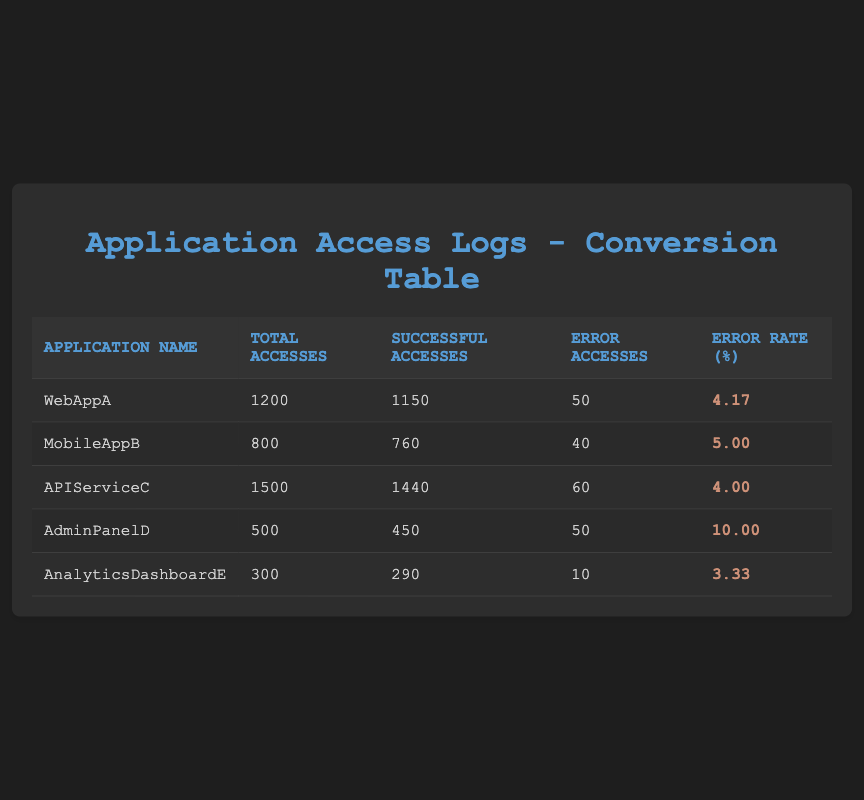What is the total number of accesses for WebAppA? The table shows the total accesses for WebAppA in the "Total Accesses" column, which is directly stated as 1200.
Answer: 1200 What is the error rate for APIServiceC? The error rate for APIServiceC can be found in the "Error Rate (%)" column next to the application's name, which shows a value of 4.00.
Answer: 4.00 Which application has the highest error rate? By comparing the "Error Rate (%)" values, AdminPanelD shows the highest value at 10.00, making it the application with the highest error rate.
Answer: AdminPanelD What is the sum of successful accesses for all applications? The successful accesses are summed up from each application's "Successful Accesses" values: 1150 + 760 + 1440 + 450 + 290 = 4090.
Answer: 4090 Is the error rate for AnalyticsDashboardE less than 5%? Looking at the error rate for AnalyticsDashboardE, which is 3.33%, we can confirm it is indeed less than 5%.
Answer: Yes What is the average error rate across all applications? The average error rate is calculated by summing the error rates: (4.17 + 5.00 + 4.00 + 10.00 + 3.33) = 26.50, and dividing by the number of applications (5) leads to an average of 26.50 / 5 = 5.30.
Answer: 5.30 How many applications have error accesses greater than 40? By examining the "Error Accesses" column, we find that WebAppA, APIServiceC, and AdminPanelD have error accesses of 50, 60, and 50 respectively, totaling three applications with more than 40 error accesses.
Answer: 3 Which application has the lowest total accesses? Looking at the "Total Accesses" column, AnalyticsDashboardE has the lowest value at 300, indicating it has the least number of total accesses among the applications listed.
Answer: AnalyticsDashboardE What is the difference in successful accesses between MobileAppB and AdminPanelD? The difference is calculated by subtracting AdminPanelD's successful accesses (450) from MobileAppB's (760): 760 - 450 = 310.
Answer: 310 